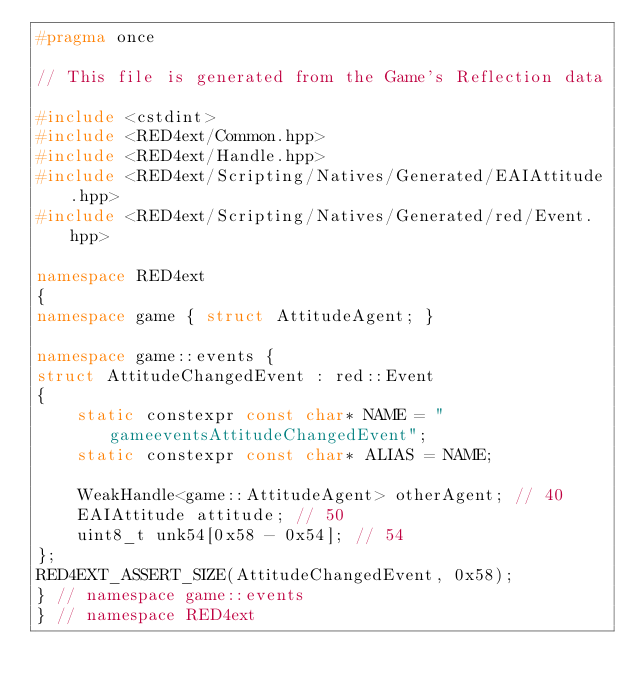Convert code to text. <code><loc_0><loc_0><loc_500><loc_500><_C++_>#pragma once

// This file is generated from the Game's Reflection data

#include <cstdint>
#include <RED4ext/Common.hpp>
#include <RED4ext/Handle.hpp>
#include <RED4ext/Scripting/Natives/Generated/EAIAttitude.hpp>
#include <RED4ext/Scripting/Natives/Generated/red/Event.hpp>

namespace RED4ext
{
namespace game { struct AttitudeAgent; }

namespace game::events { 
struct AttitudeChangedEvent : red::Event
{
    static constexpr const char* NAME = "gameeventsAttitudeChangedEvent";
    static constexpr const char* ALIAS = NAME;

    WeakHandle<game::AttitudeAgent> otherAgent; // 40
    EAIAttitude attitude; // 50
    uint8_t unk54[0x58 - 0x54]; // 54
};
RED4EXT_ASSERT_SIZE(AttitudeChangedEvent, 0x58);
} // namespace game::events
} // namespace RED4ext
</code> 